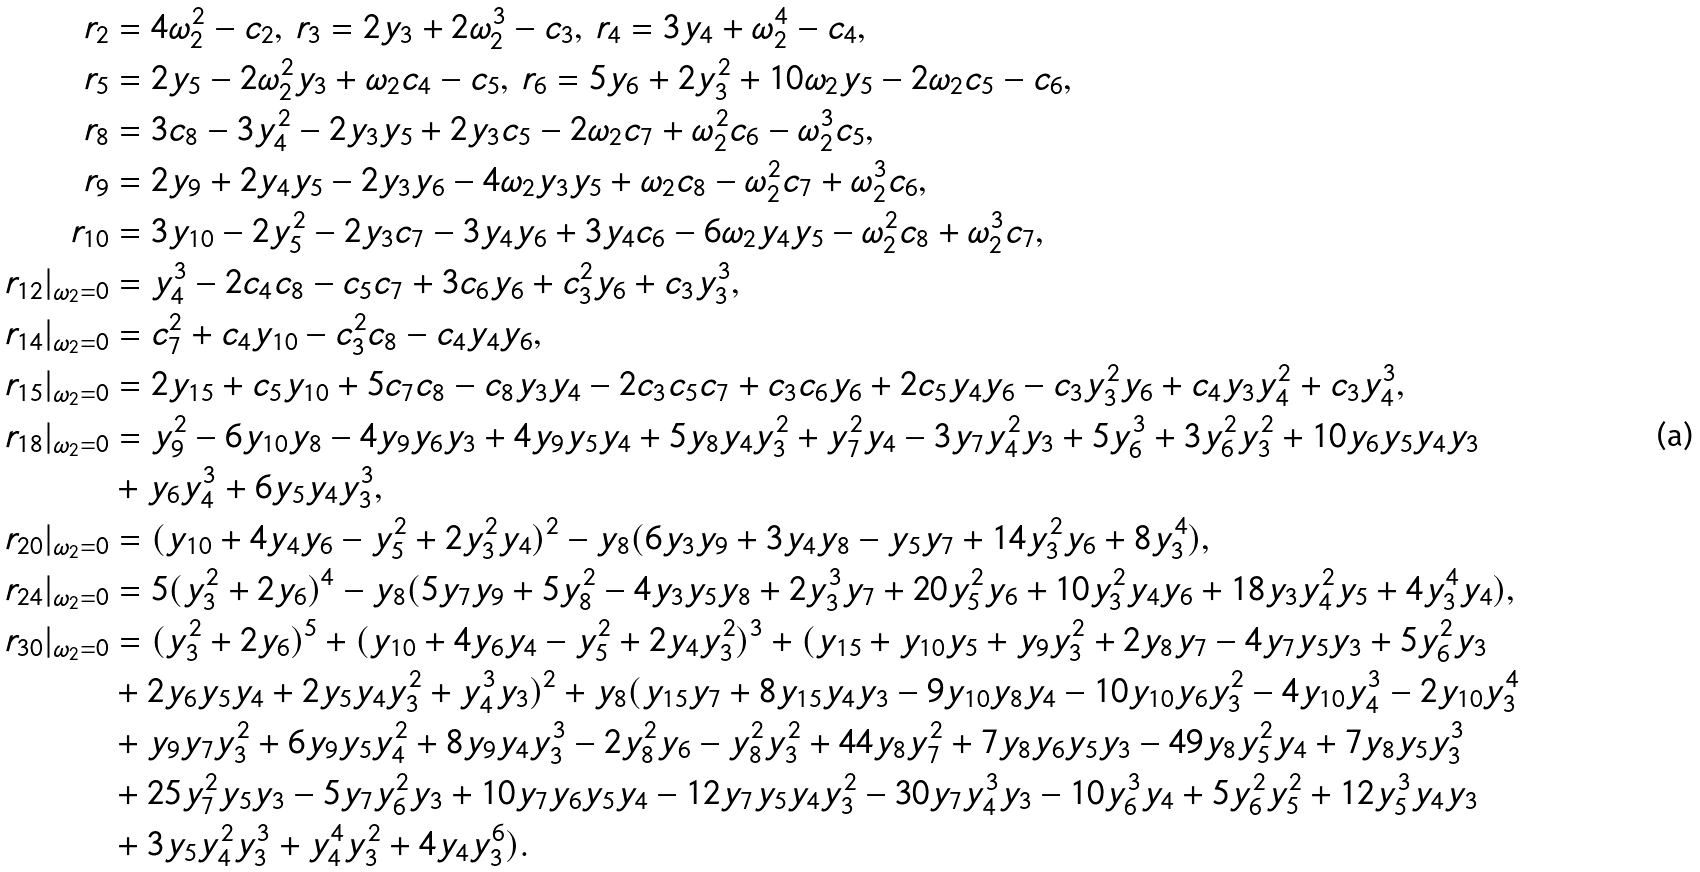<formula> <loc_0><loc_0><loc_500><loc_500>r _ { 2 } & = 4 \omega _ { 2 } ^ { 2 } - c _ { 2 } , \, r _ { 3 } = 2 y _ { 3 } + 2 \omega _ { 2 } ^ { 3 } - c _ { 3 } , \, r _ { 4 } = 3 y _ { 4 } + \omega _ { 2 } ^ { 4 } - c _ { 4 } , \\ r _ { 5 } & = 2 y _ { 5 } - 2 \omega _ { 2 } ^ { 2 } y _ { 3 } + \omega _ { 2 } c _ { 4 } - c _ { 5 } , \, r _ { 6 } = 5 y _ { 6 } + 2 y _ { 3 } ^ { 2 } + 1 0 \omega _ { 2 } y _ { 5 } - 2 \omega _ { 2 } c _ { 5 } - c _ { 6 } , \\ r _ { 8 } & = 3 { c _ { 8 } } - 3 { y _ { 4 } ^ { 2 } } - 2 { y _ { 3 } y _ { 5 } } + 2 { y _ { 3 } } c _ { 5 } - { 2 \omega _ { 2 } c _ { 7 } } + { \omega _ { 2 } ^ { 2 } c _ { 6 } - \omega _ { 2 } ^ { 3 } c _ { 5 } } , \\ r _ { 9 } & = 2 { y _ { 9 } } + 2 { y _ { 4 } y _ { 5 } } - 2 { y _ { 3 } y _ { 6 } } - 4 { { \omega _ { 2 } } y _ { 3 } y _ { 5 } + { \omega _ { 2 } c _ { 8 } } - \omega _ { 2 } ^ { 2 } c _ { 7 } } + { \omega _ { 2 } ^ { 3 } c _ { 6 } } , \\ r _ { 1 0 } & = 3 { { y _ { 1 0 } - 2 { y _ { 5 } ^ { 2 } } - 2 { y _ { 3 } c _ { 7 } } - 3 { y _ { 4 } y _ { 6 } + 3 { y _ { 4 } } c _ { 6 } } - 6 \omega _ { 2 } { y _ { 4 } y _ { 5 } } } } - { \omega _ { 2 } ^ { 2 } c _ { 8 } } + { \omega _ { 2 } ^ { 3 } c _ { 7 } } , \\ r _ { 1 2 } | _ { \omega _ { 2 } = 0 } & = y _ { 4 } ^ { 3 } - 2 c _ { 4 } c _ { 8 } - c _ { 5 } c _ { 7 } + 3 c _ { 6 } y _ { 6 } + c _ { 3 } ^ { 2 } y _ { 6 } + c _ { 3 } y _ { 3 } ^ { 3 } , \\ r _ { 1 4 } | _ { \omega _ { 2 } = 0 } & = c _ { 7 } ^ { 2 } + c _ { 4 } y _ { 1 0 } - c _ { 3 } ^ { 2 } c _ { 8 } - c _ { 4 } y _ { 4 } y _ { 6 } , \\ r _ { 1 5 } | _ { \omega _ { 2 } = 0 } & = 2 y _ { 1 5 } + c _ { 5 } y _ { 1 0 } + 5 c _ { 7 } c _ { 8 } - c _ { 8 } y _ { 3 } y _ { 4 } - 2 c _ { 3 } c _ { 5 } c _ { 7 } + c _ { 3 } c _ { 6 } y _ { 6 } + 2 c _ { 5 } y _ { 4 } y _ { 6 } - c _ { 3 } y _ { 3 } ^ { 2 } y _ { 6 } + c _ { 4 } y _ { 3 } y _ { 4 } ^ { 2 } + c _ { 3 } y _ { 4 } ^ { 3 } , \\ r _ { 1 8 } | _ { \omega _ { 2 } = 0 } & = y _ { 9 } ^ { 2 } - 6 y _ { 1 0 } y _ { 8 } - 4 y _ { 9 } y _ { 6 } y _ { 3 } + 4 y _ { 9 } y _ { 5 } y _ { 4 } + 5 y _ { 8 } y _ { 4 } y _ { 3 } ^ { 2 } + y _ { 7 } ^ { 2 } y _ { 4 } - 3 y _ { 7 } y _ { 4 } ^ { 2 } y _ { 3 } + 5 y _ { 6 } ^ { 3 } + 3 y _ { 6 } ^ { 2 } y _ { 3 } ^ { 2 } + 1 0 y _ { 6 } y _ { 5 } y _ { 4 } y _ { 3 } \\ & + y _ { 6 } y _ { 4 } ^ { 3 } + 6 y _ { 5 } y _ { 4 } y _ { 3 } ^ { 3 } , \\ r _ { 2 0 } | _ { \omega _ { 2 } = 0 } & = ( y _ { 1 0 } + 4 y _ { 4 } y _ { 6 } - y _ { 5 } ^ { 2 } + 2 y _ { 3 } ^ { 2 } y _ { 4 } ) ^ { 2 } - y _ { 8 } ( 6 y _ { 3 } y _ { 9 } + 3 y _ { 4 } y _ { 8 } - y _ { 5 } y _ { 7 } + 1 4 y _ { 3 } ^ { 2 } y _ { 6 } + 8 y _ { 3 } ^ { 4 } ) , \\ r _ { 2 4 } | _ { \omega _ { 2 } = 0 } & = 5 ( y _ { 3 } ^ { 2 } + 2 y _ { 6 } ) ^ { 4 } - y _ { 8 } ( 5 y _ { 7 } y _ { 9 } + 5 y _ { 8 } ^ { 2 } - 4 y _ { 3 } y _ { 5 } y _ { 8 } + 2 y _ { 3 } ^ { 3 } y _ { 7 } + 2 0 y _ { 5 } ^ { 2 } y _ { 6 } + 1 0 y _ { 3 } ^ { 2 } y _ { 4 } y _ { 6 } + 1 8 y _ { 3 } y _ { 4 } ^ { 2 } y _ { 5 } + 4 y _ { 3 } ^ { 4 } y _ { 4 } ) , \\ r _ { 3 0 } | _ { \omega _ { 2 } = 0 } & = ( y _ { 3 } ^ { 2 } + 2 y _ { 6 } ) ^ { 5 } + ( y _ { 1 0 } + 4 y _ { 6 } y _ { 4 } - y _ { 5 } ^ { 2 } + 2 y _ { 4 } y _ { 3 } ^ { 2 } ) ^ { 3 } + ( y _ { 1 5 } + y _ { 1 0 } y _ { 5 } + y _ { 9 } y _ { 3 } ^ { 2 } + 2 y _ { 8 } y _ { 7 } - 4 y _ { 7 } y _ { 5 } y _ { 3 } + 5 y _ { 6 } ^ { 2 } y _ { 3 } \\ & + 2 y _ { 6 } y _ { 5 } y _ { 4 } + 2 y _ { 5 } y _ { 4 } y _ { 3 } ^ { 2 } + y _ { 4 } ^ { 3 } y _ { 3 } ) ^ { 2 } + y _ { 8 } ( y _ { 1 5 } y _ { 7 } + 8 y _ { 1 5 } y _ { 4 } y _ { 3 } - 9 y _ { 1 0 } y _ { 8 } y _ { 4 } - 1 0 y _ { 1 0 } y _ { 6 } y _ { 3 } ^ { 2 } - 4 y _ { 1 0 } y _ { 4 } ^ { 3 } - 2 y _ { 1 0 } y _ { 3 } ^ { 4 } \\ & + y _ { 9 } y _ { 7 } y _ { 3 } ^ { 2 } + 6 y _ { 9 } y _ { 5 } y _ { 4 } ^ { 2 } + 8 y _ { 9 } y _ { 4 } y _ { 3 } ^ { 3 } - 2 y _ { 8 } ^ { 2 } y _ { 6 } - y _ { 8 } ^ { 2 } y _ { 3 } ^ { 2 } + 4 4 y _ { 8 } y _ { 7 } ^ { 2 } + 7 y _ { 8 } y _ { 6 } y _ { 5 } y _ { 3 } - 4 9 y _ { 8 } y _ { 5 } ^ { 2 } y _ { 4 } + 7 y _ { 8 } y _ { 5 } y _ { 3 } ^ { 3 } \\ & + 2 5 y _ { 7 } ^ { 2 } y _ { 5 } y _ { 3 } - 5 y _ { 7 } y _ { 6 } ^ { 2 } y _ { 3 } + 1 0 y _ { 7 } y _ { 6 } y _ { 5 } y _ { 4 } - 1 2 y _ { 7 } y _ { 5 } y _ { 4 } y _ { 3 } ^ { 2 } - 3 0 y _ { 7 } y _ { 4 } ^ { 3 } y _ { 3 } - 1 0 y _ { 6 } ^ { 3 } y _ { 4 } + 5 y _ { 6 } ^ { 2 } y _ { 5 } ^ { 2 } + 1 2 y _ { 5 } ^ { 3 } y _ { 4 } y _ { 3 } \\ & + 3 y _ { 5 } y _ { 4 } ^ { 2 } y _ { 3 } ^ { 3 } + y _ { 4 } ^ { 4 } y _ { 3 } ^ { 2 } + 4 y _ { 4 } y _ { 3 } ^ { 6 } ) .</formula> 